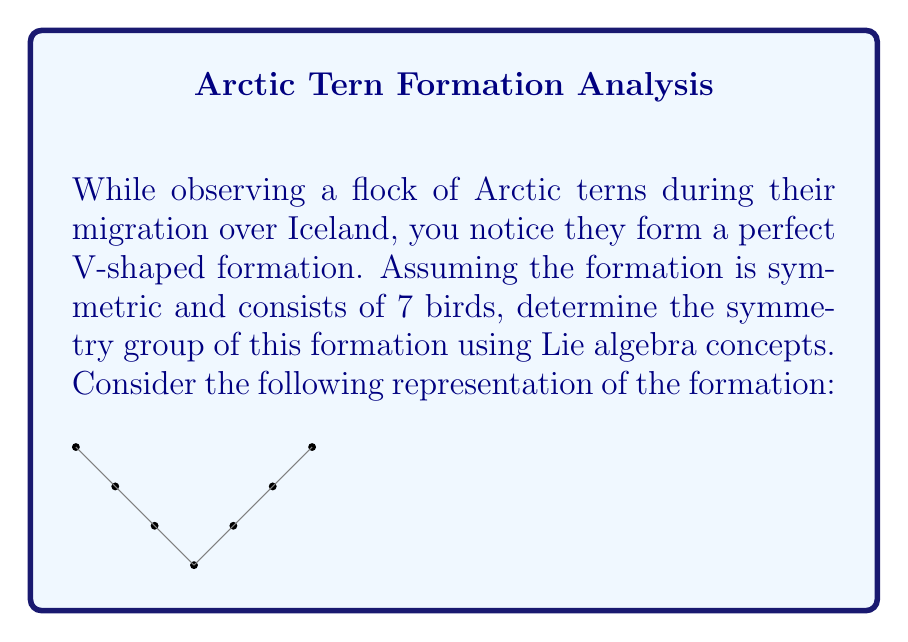Provide a solution to this math problem. To determine the symmetry group of the V-shaped bird formation, we'll follow these steps:

1) First, we identify the symmetries of the formation:
   - Reflection about the vertical axis
   - Identity transformation (no change)

2) These symmetries form a group isomorphic to $\mathbb{Z}_2$, the cyclic group of order 2.

3) To represent this group using Lie algebra concepts, we can use the special orthogonal group $SO(2)$, which describes rotations in 2D space.

4) The Lie algebra $\mathfrak{so}(2)$ of $SO(2)$ is one-dimensional, generated by the matrix:

   $$J = \begin{pmatrix} 0 & -1 \\ 1 & 0 \end{pmatrix}$$

5) The reflection symmetry can be represented by the matrix:

   $$R = \begin{pmatrix} -1 & 0 \\ 0 & 1 \end{pmatrix}$$

6) The group elements can be obtained by exponentiating the Lie algebra element:

   $$\exp(0 \cdot J) = I \quad \text{(Identity)}$$
   $$\exp(\pi \cdot J) = -I \quad \text{(Rotation by 180°)}$$

7) However, the reflection $R$ is not in the connected component of the identity in $O(2)$, so it's not generated by the Lie algebra directly.

8) The full symmetry group is thus a discrete subgroup of $O(2)$, isomorphic to $\mathbb{Z}_2$, consisting of $\{I, R\}$.
Answer: $\mathbb{Z}_2$ (discrete subgroup of $O(2)$) 